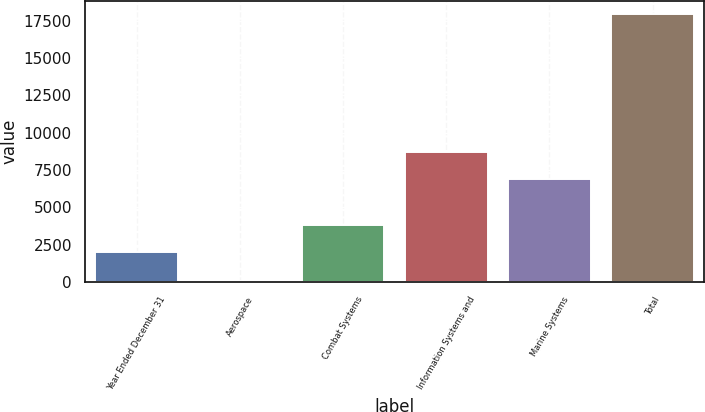Convert chart to OTSL. <chart><loc_0><loc_0><loc_500><loc_500><bar_chart><fcel>Year Ended December 31<fcel>Aerospace<fcel>Combat Systems<fcel>Information Systems and<fcel>Marine Systems<fcel>Total<nl><fcel>2014<fcel>99<fcel>3799.6<fcel>8686.6<fcel>6901<fcel>17955<nl></chart> 